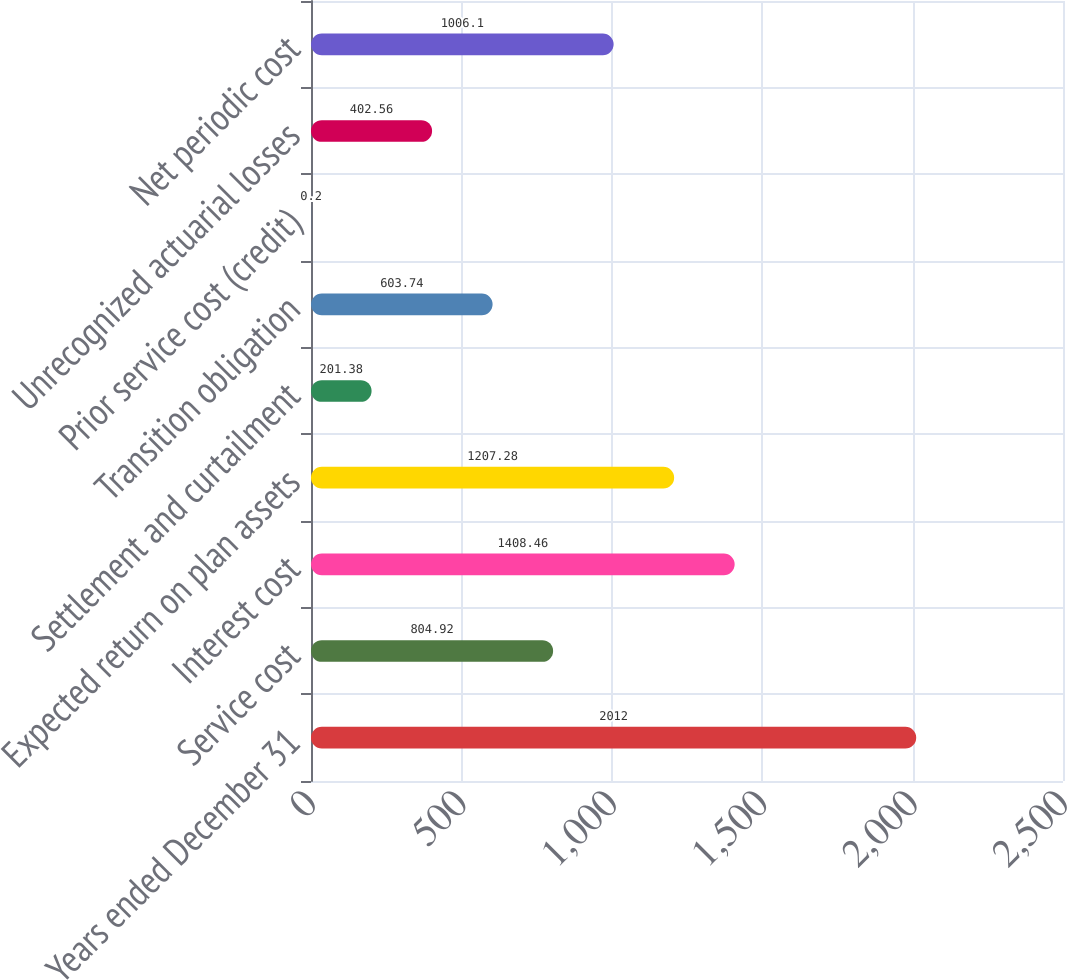Convert chart. <chart><loc_0><loc_0><loc_500><loc_500><bar_chart><fcel>Years ended December 31<fcel>Service cost<fcel>Interest cost<fcel>Expected return on plan assets<fcel>Settlement and curtailment<fcel>Transition obligation<fcel>Prior service cost (credit)<fcel>Unrecognized actuarial losses<fcel>Net periodic cost<nl><fcel>2012<fcel>804.92<fcel>1408.46<fcel>1207.28<fcel>201.38<fcel>603.74<fcel>0.2<fcel>402.56<fcel>1006.1<nl></chart> 